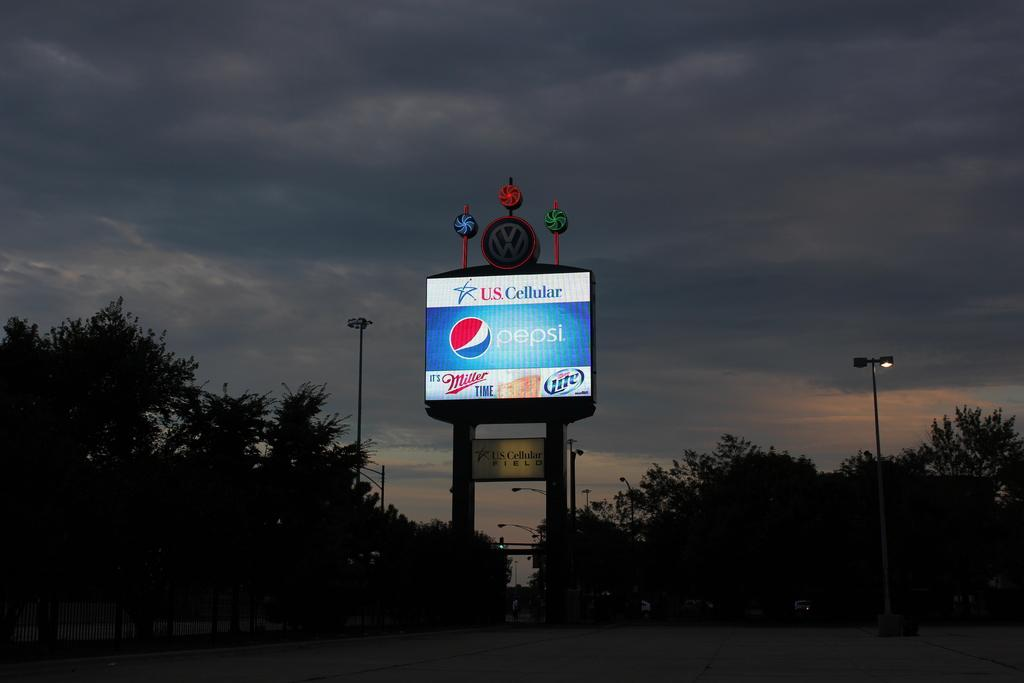<image>
Relay a brief, clear account of the picture shown. Alarge billboard with US. Cellular and Pepsi advertisements on it 